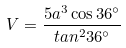<formula> <loc_0><loc_0><loc_500><loc_500>V = \frac { 5 a ^ { 3 } \cos 3 6 ^ { \circ } } { t a n ^ { 2 } 3 6 ^ { \circ } }</formula> 